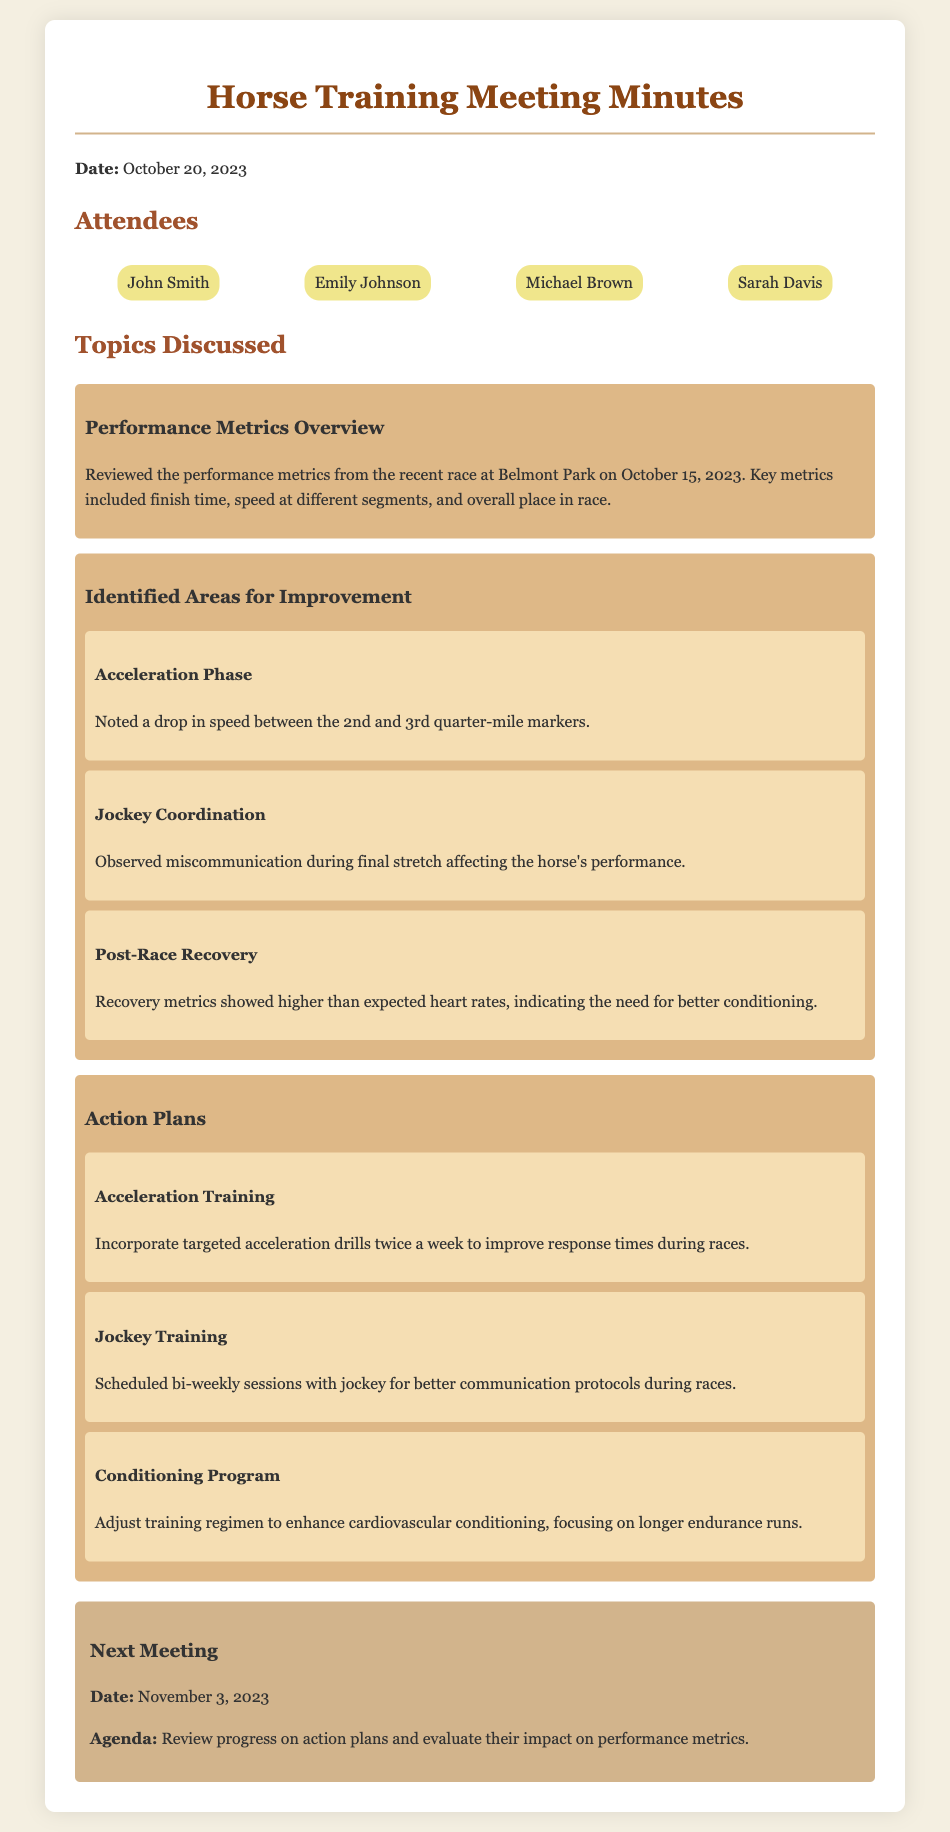What was the date of the recent race? The recent race at Belmont Park took place on October 15, 2023.
Answer: October 15, 2023 Who noted the drop in speed during the acceleration phase? The document does not specify an individual; it mentions a general observation.
Answer: Not specified What specific area shows a need for better communication? There was miscommunication observed during the final stretch affecting performance.
Answer: Jockey Coordination How many action plans were discussed? The document outlines three distinct action plans for improvement.
Answer: Three When is the next meeting scheduled? The next meeting date is listed in the document as November 3, 2023.
Answer: November 3, 2023 Which performance metric indicated the need for better conditioning? The recovery metrics showed higher than expected heart rates.
Answer: Heart rates What type of drills will be incorporated to improve acceleration? Targeted acceleration drills will be implemented twice a week.
Answer: Acceleration drills What is the main focus of the conditioning program action plan? The action plan focuses on enhancing cardiovascular conditioning.
Answer: Cardiovascular conditioning 